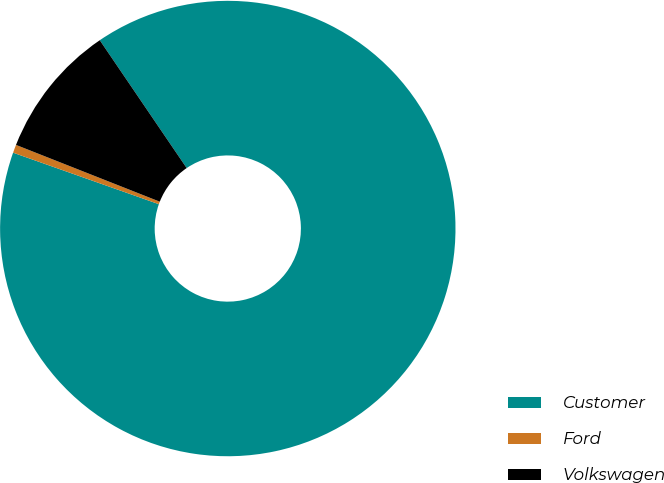Convert chart. <chart><loc_0><loc_0><loc_500><loc_500><pie_chart><fcel>Customer<fcel>Ford<fcel>Volkswagen<nl><fcel>89.91%<fcel>0.58%<fcel>9.51%<nl></chart> 